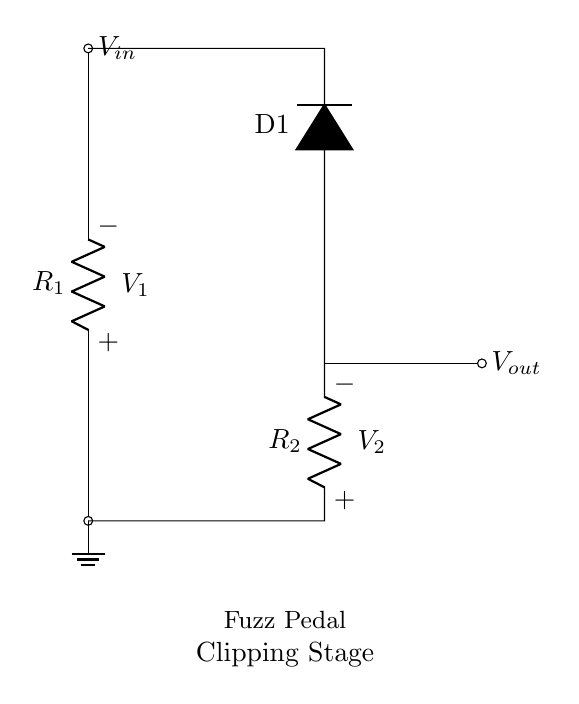What type of circuit is this? This circuit is a voltage divider, which consists of two resistors in series that divide the input voltage. The output voltage is taken from the junction of the two resistors.
Answer: Voltage divider What is the value of R1 labeled in the circuit? The circuit shows a label for R1, but it doesn't specify a numerical value. It's typically variable depending on the design.
Answer: Not specified Where is the output voltage taken from? The output voltage, denoted as Vout, is taken from the junction between the two resistors, which is highlighted in the diagram.
Answer: From the junction of R1 and R2 What component is used for clipping in this circuit? The circuit depicts a diode (D1) which is responsible for clipping the signal, typically to create distortion in a pedal circuit.
Answer: Diode How does the input voltage interact with the resistors? The input voltage (Vin) applies across both resistors, causing a voltage drop according to the resistor values. The output voltage can be calculated using the voltage divider rule.
Answer: Voltage divider rule What purpose does R2 serve in the voltage divider? R2 works with R1 to determine the output voltage. Together, they set the ratio of the voltages, influencing the clipping characteristics of the pedal based on their values.
Answer: Sets output voltage ratio Is there a ground connection in this circuit? Yes, the ground is indicated at the bottom of the circuit diagram, providing a reference point for the voltages in the circuit.
Answer: Yes 